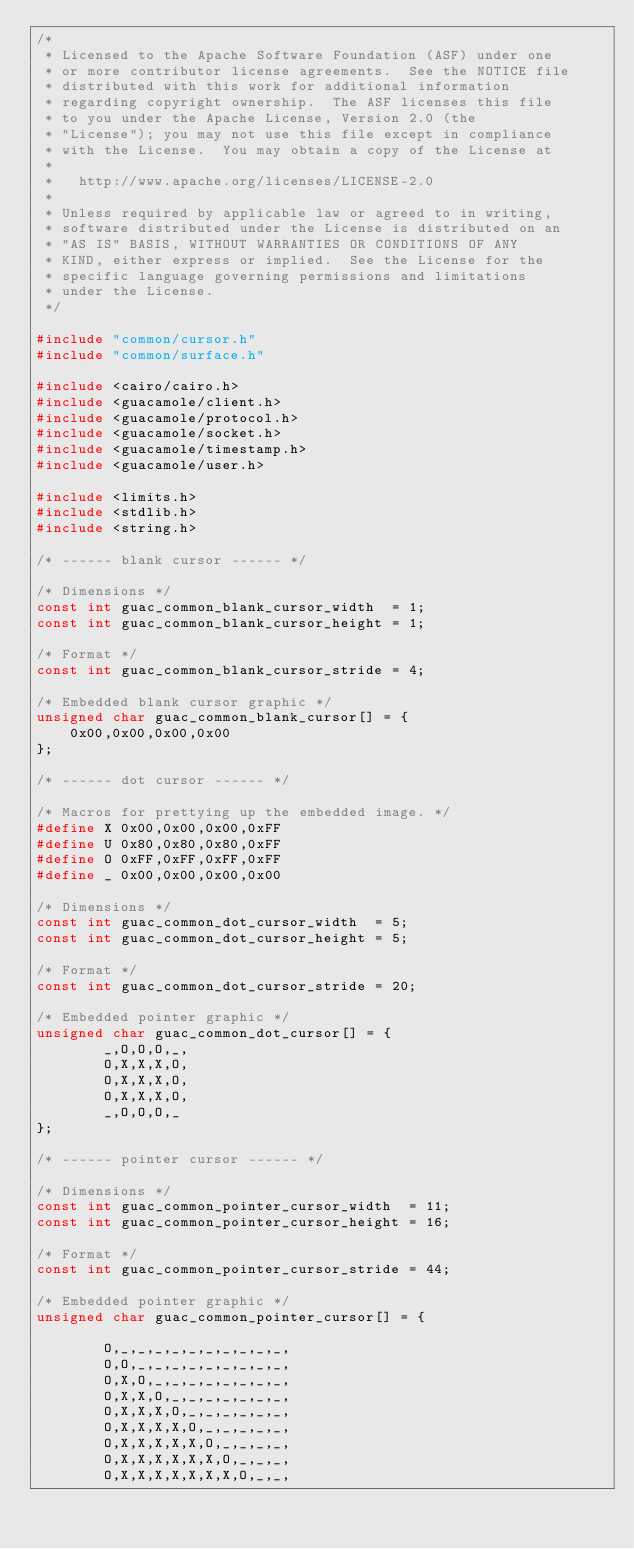<code> <loc_0><loc_0><loc_500><loc_500><_C_>/*
 * Licensed to the Apache Software Foundation (ASF) under one
 * or more contributor license agreements.  See the NOTICE file
 * distributed with this work for additional information
 * regarding copyright ownership.  The ASF licenses this file
 * to you under the Apache License, Version 2.0 (the
 * "License"); you may not use this file except in compliance
 * with the License.  You may obtain a copy of the License at
 *
 *   http://www.apache.org/licenses/LICENSE-2.0
 *
 * Unless required by applicable law or agreed to in writing,
 * software distributed under the License is distributed on an
 * "AS IS" BASIS, WITHOUT WARRANTIES OR CONDITIONS OF ANY
 * KIND, either express or implied.  See the License for the
 * specific language governing permissions and limitations
 * under the License.
 */

#include "common/cursor.h"
#include "common/surface.h"

#include <cairo/cairo.h>
#include <guacamole/client.h>
#include <guacamole/protocol.h>
#include <guacamole/socket.h>
#include <guacamole/timestamp.h>
#include <guacamole/user.h>

#include <limits.h>
#include <stdlib.h>
#include <string.h>

/* ------ blank cursor ------ */

/* Dimensions */
const int guac_common_blank_cursor_width  = 1;
const int guac_common_blank_cursor_height = 1;

/* Format */
const int guac_common_blank_cursor_stride = 4;

/* Embedded blank cursor graphic */
unsigned char guac_common_blank_cursor[] = {
    0x00,0x00,0x00,0x00
};

/* ------ dot cursor ------ */

/* Macros for prettying up the embedded image. */
#define X 0x00,0x00,0x00,0xFF
#define U 0x80,0x80,0x80,0xFF
#define O 0xFF,0xFF,0xFF,0xFF
#define _ 0x00,0x00,0x00,0x00

/* Dimensions */
const int guac_common_dot_cursor_width  = 5;
const int guac_common_dot_cursor_height = 5;

/* Format */
const int guac_common_dot_cursor_stride = 20;

/* Embedded pointer graphic */
unsigned char guac_common_dot_cursor[] = {
        _,O,O,O,_,
        O,X,X,X,O,
        O,X,X,X,O,
        O,X,X,X,O,
        _,O,O,O,_
};

/* ------ pointer cursor ------ */

/* Dimensions */
const int guac_common_pointer_cursor_width  = 11;
const int guac_common_pointer_cursor_height = 16;

/* Format */
const int guac_common_pointer_cursor_stride = 44;

/* Embedded pointer graphic */
unsigned char guac_common_pointer_cursor[] = {

        O,_,_,_,_,_,_,_,_,_,_,
        O,O,_,_,_,_,_,_,_,_,_,
        O,X,O,_,_,_,_,_,_,_,_,
        O,X,X,O,_,_,_,_,_,_,_,
        O,X,X,X,O,_,_,_,_,_,_,
        O,X,X,X,X,O,_,_,_,_,_,
        O,X,X,X,X,X,O,_,_,_,_,
        O,X,X,X,X,X,X,O,_,_,_,
        O,X,X,X,X,X,X,X,O,_,_,</code> 